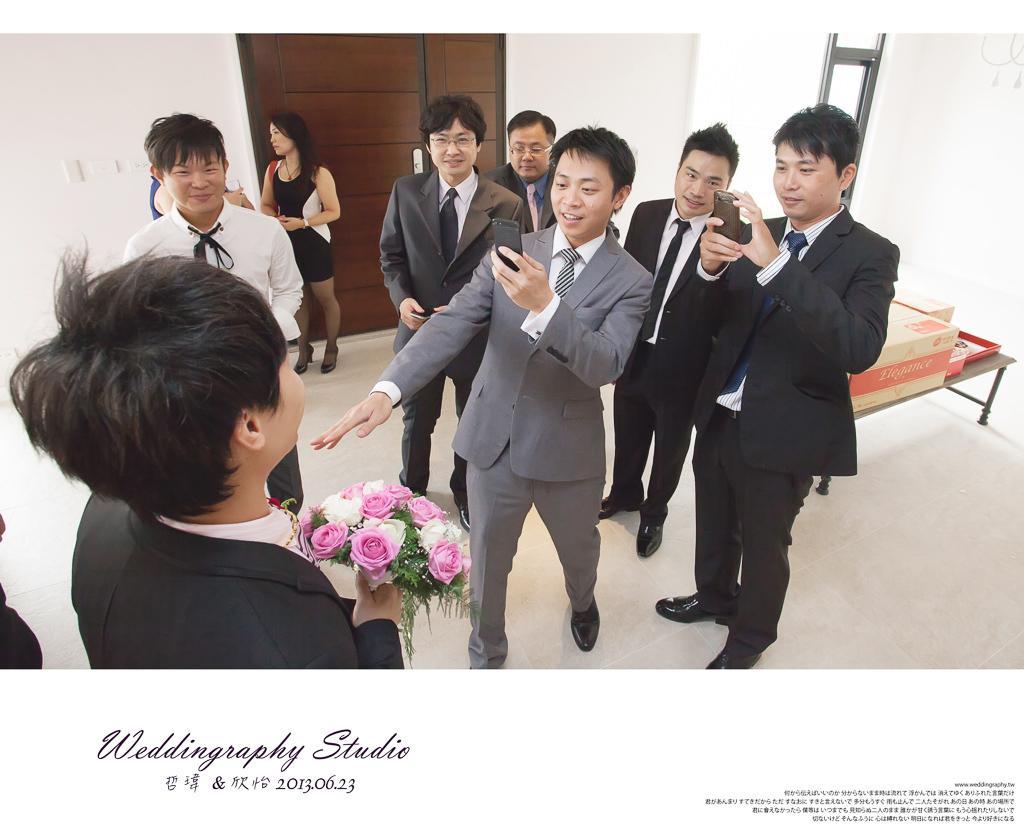Can you describe this image briefly? This is an edited image. On the left there is a person wearing suit, holding a bouquet and standing. On the right we can see the group of persons wearing suits, holding some objects and standing on the ground. In the background there is a woman wearing black color dress and standing on the ground and we can see the wooden door, wall and some other objects. 